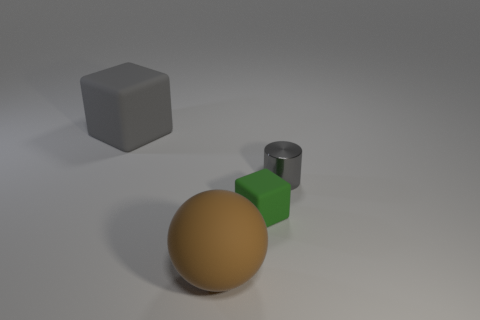Add 3 tiny green things. How many objects exist? 7 Subtract all cylinders. How many objects are left? 3 Add 4 small cylinders. How many small cylinders are left? 5 Add 2 large green rubber spheres. How many large green rubber spheres exist? 2 Subtract 0 blue balls. How many objects are left? 4 Subtract all small yellow rubber spheres. Subtract all brown spheres. How many objects are left? 3 